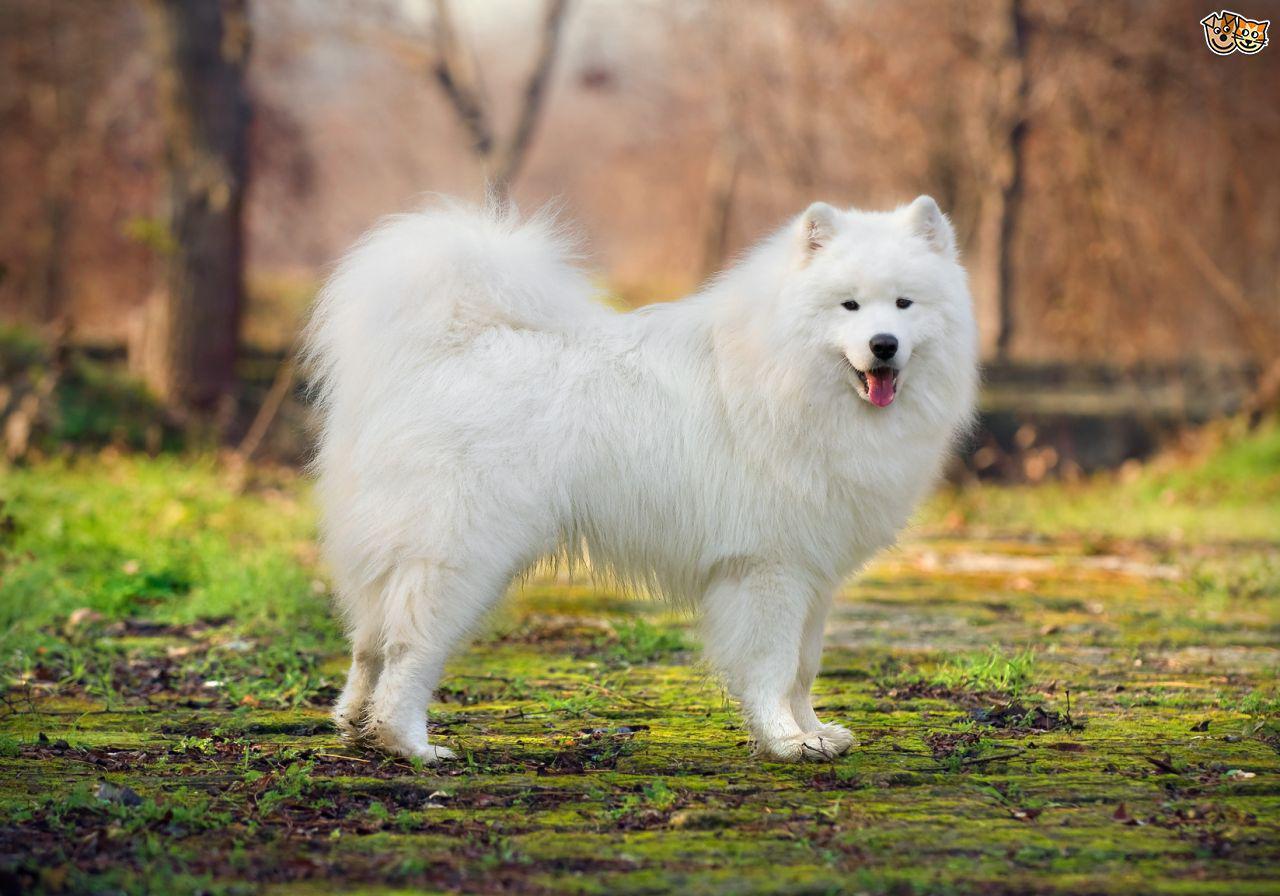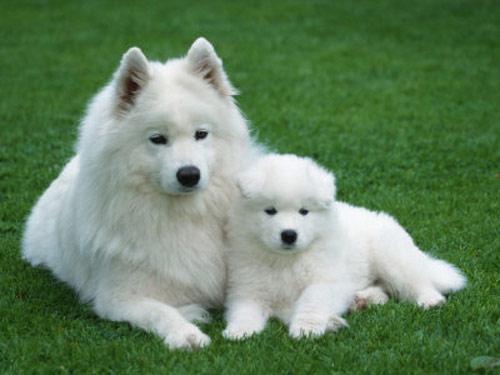The first image is the image on the left, the second image is the image on the right. Analyze the images presented: Is the assertion "One image features one or more white dogs reclining on grass." valid? Answer yes or no. Yes. 